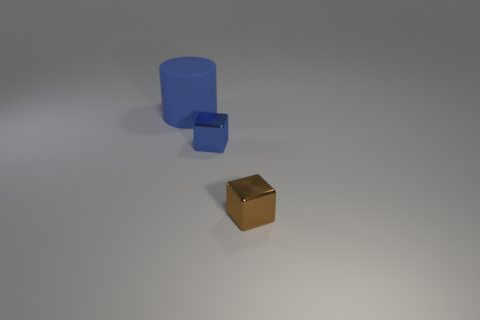There is a blue thing that is the same material as the brown block; what size is it?
Offer a terse response. Small. What is the color of the tiny thing that is right of the blue object in front of the big blue object?
Offer a very short reply. Brown. There is a big matte object; is its shape the same as the metal object that is in front of the blue shiny object?
Your answer should be very brief. No. What number of green balls have the same size as the blue metallic thing?
Your answer should be very brief. 0. What is the material of the other thing that is the same shape as the small blue shiny object?
Ensure brevity in your answer.  Metal. There is a big matte cylinder behind the brown shiny thing; is its color the same as the tiny metallic cube that is left of the brown block?
Make the answer very short. Yes. There is a tiny thing on the right side of the blue cube; what shape is it?
Ensure brevity in your answer.  Cube. The large object has what color?
Keep it short and to the point. Blue. There is a blue object that is the same material as the brown block; what shape is it?
Offer a very short reply. Cube. Does the block on the right side of the blue metallic thing have the same size as the large blue matte cylinder?
Your answer should be very brief. No. 